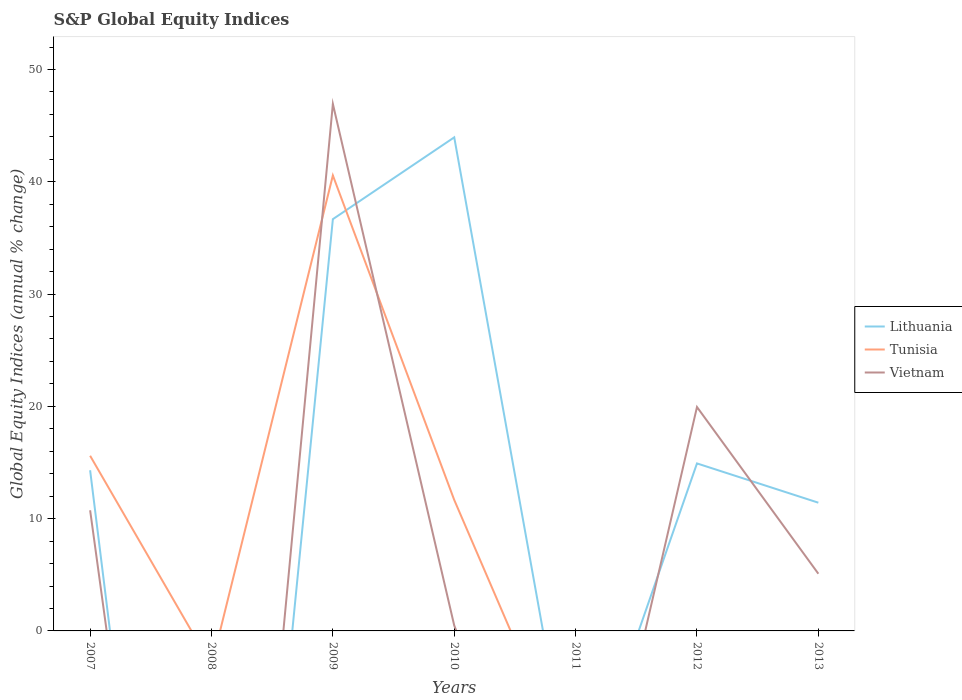Does the line corresponding to Vietnam intersect with the line corresponding to Tunisia?
Provide a succinct answer. Yes. Across all years, what is the maximum global equity indices in Vietnam?
Provide a short and direct response. 0. What is the total global equity indices in Lithuania in the graph?
Give a very brief answer. 21.75. What is the difference between the highest and the second highest global equity indices in Lithuania?
Provide a succinct answer. 43.96. What is the difference between the highest and the lowest global equity indices in Vietnam?
Make the answer very short. 2. Is the global equity indices in Tunisia strictly greater than the global equity indices in Lithuania over the years?
Offer a very short reply. No. How many lines are there?
Your response must be concise. 3. Are the values on the major ticks of Y-axis written in scientific E-notation?
Give a very brief answer. No. Does the graph contain grids?
Offer a terse response. No. How many legend labels are there?
Ensure brevity in your answer.  3. How are the legend labels stacked?
Keep it short and to the point. Vertical. What is the title of the graph?
Offer a terse response. S&P Global Equity Indices. What is the label or title of the X-axis?
Offer a terse response. Years. What is the label or title of the Y-axis?
Ensure brevity in your answer.  Global Equity Indices (annual % change). What is the Global Equity Indices (annual % change) of Lithuania in 2007?
Offer a very short reply. 14.31. What is the Global Equity Indices (annual % change) in Tunisia in 2007?
Your answer should be compact. 15.6. What is the Global Equity Indices (annual % change) in Vietnam in 2007?
Give a very brief answer. 10.74. What is the Global Equity Indices (annual % change) in Lithuania in 2008?
Offer a very short reply. 0. What is the Global Equity Indices (annual % change) of Tunisia in 2008?
Make the answer very short. 0. What is the Global Equity Indices (annual % change) in Lithuania in 2009?
Offer a terse response. 36.67. What is the Global Equity Indices (annual % change) of Tunisia in 2009?
Make the answer very short. 40.57. What is the Global Equity Indices (annual % change) in Vietnam in 2009?
Offer a terse response. 46.93. What is the Global Equity Indices (annual % change) in Lithuania in 2010?
Your response must be concise. 43.96. What is the Global Equity Indices (annual % change) in Tunisia in 2010?
Keep it short and to the point. 11.66. What is the Global Equity Indices (annual % change) in Vietnam in 2010?
Provide a short and direct response. 0.48. What is the Global Equity Indices (annual % change) of Lithuania in 2011?
Keep it short and to the point. 0. What is the Global Equity Indices (annual % change) of Vietnam in 2011?
Your answer should be very brief. 0. What is the Global Equity Indices (annual % change) in Lithuania in 2012?
Keep it short and to the point. 14.92. What is the Global Equity Indices (annual % change) of Tunisia in 2012?
Ensure brevity in your answer.  0. What is the Global Equity Indices (annual % change) in Vietnam in 2012?
Keep it short and to the point. 19.94. What is the Global Equity Indices (annual % change) of Lithuania in 2013?
Offer a very short reply. 11.42. What is the Global Equity Indices (annual % change) in Tunisia in 2013?
Keep it short and to the point. 0. What is the Global Equity Indices (annual % change) in Vietnam in 2013?
Offer a very short reply. 5.09. Across all years, what is the maximum Global Equity Indices (annual % change) in Lithuania?
Ensure brevity in your answer.  43.96. Across all years, what is the maximum Global Equity Indices (annual % change) in Tunisia?
Offer a very short reply. 40.57. Across all years, what is the maximum Global Equity Indices (annual % change) of Vietnam?
Provide a short and direct response. 46.93. Across all years, what is the minimum Global Equity Indices (annual % change) of Vietnam?
Your response must be concise. 0. What is the total Global Equity Indices (annual % change) in Lithuania in the graph?
Offer a terse response. 121.27. What is the total Global Equity Indices (annual % change) in Tunisia in the graph?
Offer a very short reply. 67.83. What is the total Global Equity Indices (annual % change) of Vietnam in the graph?
Keep it short and to the point. 83.19. What is the difference between the Global Equity Indices (annual % change) in Lithuania in 2007 and that in 2009?
Your answer should be compact. -22.36. What is the difference between the Global Equity Indices (annual % change) in Tunisia in 2007 and that in 2009?
Make the answer very short. -24.97. What is the difference between the Global Equity Indices (annual % change) in Vietnam in 2007 and that in 2009?
Make the answer very short. -36.19. What is the difference between the Global Equity Indices (annual % change) in Lithuania in 2007 and that in 2010?
Provide a succinct answer. -29.65. What is the difference between the Global Equity Indices (annual % change) in Tunisia in 2007 and that in 2010?
Your response must be concise. 3.94. What is the difference between the Global Equity Indices (annual % change) of Vietnam in 2007 and that in 2010?
Ensure brevity in your answer.  10.26. What is the difference between the Global Equity Indices (annual % change) of Lithuania in 2007 and that in 2012?
Offer a very short reply. -0.61. What is the difference between the Global Equity Indices (annual % change) of Vietnam in 2007 and that in 2012?
Keep it short and to the point. -9.2. What is the difference between the Global Equity Indices (annual % change) in Lithuania in 2007 and that in 2013?
Your answer should be compact. 2.89. What is the difference between the Global Equity Indices (annual % change) of Vietnam in 2007 and that in 2013?
Your answer should be compact. 5.65. What is the difference between the Global Equity Indices (annual % change) in Lithuania in 2009 and that in 2010?
Your response must be concise. -7.29. What is the difference between the Global Equity Indices (annual % change) in Tunisia in 2009 and that in 2010?
Provide a short and direct response. 28.9. What is the difference between the Global Equity Indices (annual % change) of Vietnam in 2009 and that in 2010?
Ensure brevity in your answer.  46.45. What is the difference between the Global Equity Indices (annual % change) of Lithuania in 2009 and that in 2012?
Provide a short and direct response. 21.75. What is the difference between the Global Equity Indices (annual % change) of Vietnam in 2009 and that in 2012?
Make the answer very short. 26.99. What is the difference between the Global Equity Indices (annual % change) of Lithuania in 2009 and that in 2013?
Provide a succinct answer. 25.25. What is the difference between the Global Equity Indices (annual % change) in Vietnam in 2009 and that in 2013?
Keep it short and to the point. 41.84. What is the difference between the Global Equity Indices (annual % change) in Lithuania in 2010 and that in 2012?
Keep it short and to the point. 29.04. What is the difference between the Global Equity Indices (annual % change) of Vietnam in 2010 and that in 2012?
Offer a terse response. -19.46. What is the difference between the Global Equity Indices (annual % change) in Lithuania in 2010 and that in 2013?
Your answer should be compact. 32.54. What is the difference between the Global Equity Indices (annual % change) of Vietnam in 2010 and that in 2013?
Your answer should be compact. -4.61. What is the difference between the Global Equity Indices (annual % change) of Lithuania in 2012 and that in 2013?
Ensure brevity in your answer.  3.5. What is the difference between the Global Equity Indices (annual % change) of Vietnam in 2012 and that in 2013?
Provide a succinct answer. 14.85. What is the difference between the Global Equity Indices (annual % change) of Lithuania in 2007 and the Global Equity Indices (annual % change) of Tunisia in 2009?
Offer a very short reply. -26.26. What is the difference between the Global Equity Indices (annual % change) of Lithuania in 2007 and the Global Equity Indices (annual % change) of Vietnam in 2009?
Provide a succinct answer. -32.63. What is the difference between the Global Equity Indices (annual % change) of Tunisia in 2007 and the Global Equity Indices (annual % change) of Vietnam in 2009?
Your answer should be compact. -31.33. What is the difference between the Global Equity Indices (annual % change) of Lithuania in 2007 and the Global Equity Indices (annual % change) of Tunisia in 2010?
Give a very brief answer. 2.64. What is the difference between the Global Equity Indices (annual % change) in Lithuania in 2007 and the Global Equity Indices (annual % change) in Vietnam in 2010?
Keep it short and to the point. 13.83. What is the difference between the Global Equity Indices (annual % change) of Tunisia in 2007 and the Global Equity Indices (annual % change) of Vietnam in 2010?
Keep it short and to the point. 15.12. What is the difference between the Global Equity Indices (annual % change) of Lithuania in 2007 and the Global Equity Indices (annual % change) of Vietnam in 2012?
Your answer should be compact. -5.63. What is the difference between the Global Equity Indices (annual % change) in Tunisia in 2007 and the Global Equity Indices (annual % change) in Vietnam in 2012?
Provide a short and direct response. -4.34. What is the difference between the Global Equity Indices (annual % change) in Lithuania in 2007 and the Global Equity Indices (annual % change) in Vietnam in 2013?
Provide a succinct answer. 9.21. What is the difference between the Global Equity Indices (annual % change) of Tunisia in 2007 and the Global Equity Indices (annual % change) of Vietnam in 2013?
Provide a succinct answer. 10.51. What is the difference between the Global Equity Indices (annual % change) of Lithuania in 2009 and the Global Equity Indices (annual % change) of Tunisia in 2010?
Provide a succinct answer. 25.01. What is the difference between the Global Equity Indices (annual % change) of Lithuania in 2009 and the Global Equity Indices (annual % change) of Vietnam in 2010?
Your answer should be compact. 36.19. What is the difference between the Global Equity Indices (annual % change) of Tunisia in 2009 and the Global Equity Indices (annual % change) of Vietnam in 2010?
Make the answer very short. 40.08. What is the difference between the Global Equity Indices (annual % change) of Lithuania in 2009 and the Global Equity Indices (annual % change) of Vietnam in 2012?
Provide a short and direct response. 16.73. What is the difference between the Global Equity Indices (annual % change) of Tunisia in 2009 and the Global Equity Indices (annual % change) of Vietnam in 2012?
Ensure brevity in your answer.  20.62. What is the difference between the Global Equity Indices (annual % change) of Lithuania in 2009 and the Global Equity Indices (annual % change) of Vietnam in 2013?
Your answer should be very brief. 31.58. What is the difference between the Global Equity Indices (annual % change) in Tunisia in 2009 and the Global Equity Indices (annual % change) in Vietnam in 2013?
Offer a very short reply. 35.47. What is the difference between the Global Equity Indices (annual % change) of Lithuania in 2010 and the Global Equity Indices (annual % change) of Vietnam in 2012?
Offer a terse response. 24.02. What is the difference between the Global Equity Indices (annual % change) in Tunisia in 2010 and the Global Equity Indices (annual % change) in Vietnam in 2012?
Give a very brief answer. -8.28. What is the difference between the Global Equity Indices (annual % change) in Lithuania in 2010 and the Global Equity Indices (annual % change) in Vietnam in 2013?
Your response must be concise. 38.86. What is the difference between the Global Equity Indices (annual % change) of Tunisia in 2010 and the Global Equity Indices (annual % change) of Vietnam in 2013?
Offer a terse response. 6.57. What is the difference between the Global Equity Indices (annual % change) of Lithuania in 2012 and the Global Equity Indices (annual % change) of Vietnam in 2013?
Offer a terse response. 9.82. What is the average Global Equity Indices (annual % change) in Lithuania per year?
Your answer should be very brief. 17.32. What is the average Global Equity Indices (annual % change) of Tunisia per year?
Ensure brevity in your answer.  9.69. What is the average Global Equity Indices (annual % change) of Vietnam per year?
Offer a very short reply. 11.88. In the year 2007, what is the difference between the Global Equity Indices (annual % change) of Lithuania and Global Equity Indices (annual % change) of Tunisia?
Offer a very short reply. -1.29. In the year 2007, what is the difference between the Global Equity Indices (annual % change) in Lithuania and Global Equity Indices (annual % change) in Vietnam?
Ensure brevity in your answer.  3.56. In the year 2007, what is the difference between the Global Equity Indices (annual % change) of Tunisia and Global Equity Indices (annual % change) of Vietnam?
Give a very brief answer. 4.86. In the year 2009, what is the difference between the Global Equity Indices (annual % change) in Lithuania and Global Equity Indices (annual % change) in Tunisia?
Offer a terse response. -3.89. In the year 2009, what is the difference between the Global Equity Indices (annual % change) in Lithuania and Global Equity Indices (annual % change) in Vietnam?
Provide a short and direct response. -10.26. In the year 2009, what is the difference between the Global Equity Indices (annual % change) in Tunisia and Global Equity Indices (annual % change) in Vietnam?
Your answer should be compact. -6.37. In the year 2010, what is the difference between the Global Equity Indices (annual % change) in Lithuania and Global Equity Indices (annual % change) in Tunisia?
Your response must be concise. 32.29. In the year 2010, what is the difference between the Global Equity Indices (annual % change) in Lithuania and Global Equity Indices (annual % change) in Vietnam?
Your answer should be compact. 43.48. In the year 2010, what is the difference between the Global Equity Indices (annual % change) in Tunisia and Global Equity Indices (annual % change) in Vietnam?
Your answer should be very brief. 11.18. In the year 2012, what is the difference between the Global Equity Indices (annual % change) of Lithuania and Global Equity Indices (annual % change) of Vietnam?
Offer a very short reply. -5.02. In the year 2013, what is the difference between the Global Equity Indices (annual % change) in Lithuania and Global Equity Indices (annual % change) in Vietnam?
Your answer should be compact. 6.33. What is the ratio of the Global Equity Indices (annual % change) in Lithuania in 2007 to that in 2009?
Keep it short and to the point. 0.39. What is the ratio of the Global Equity Indices (annual % change) in Tunisia in 2007 to that in 2009?
Your answer should be very brief. 0.38. What is the ratio of the Global Equity Indices (annual % change) in Vietnam in 2007 to that in 2009?
Offer a very short reply. 0.23. What is the ratio of the Global Equity Indices (annual % change) of Lithuania in 2007 to that in 2010?
Give a very brief answer. 0.33. What is the ratio of the Global Equity Indices (annual % change) in Tunisia in 2007 to that in 2010?
Offer a terse response. 1.34. What is the ratio of the Global Equity Indices (annual % change) of Vietnam in 2007 to that in 2010?
Offer a very short reply. 22.36. What is the ratio of the Global Equity Indices (annual % change) of Lithuania in 2007 to that in 2012?
Your response must be concise. 0.96. What is the ratio of the Global Equity Indices (annual % change) of Vietnam in 2007 to that in 2012?
Ensure brevity in your answer.  0.54. What is the ratio of the Global Equity Indices (annual % change) of Lithuania in 2007 to that in 2013?
Offer a terse response. 1.25. What is the ratio of the Global Equity Indices (annual % change) in Vietnam in 2007 to that in 2013?
Provide a succinct answer. 2.11. What is the ratio of the Global Equity Indices (annual % change) in Lithuania in 2009 to that in 2010?
Keep it short and to the point. 0.83. What is the ratio of the Global Equity Indices (annual % change) in Tunisia in 2009 to that in 2010?
Ensure brevity in your answer.  3.48. What is the ratio of the Global Equity Indices (annual % change) of Vietnam in 2009 to that in 2010?
Make the answer very short. 97.67. What is the ratio of the Global Equity Indices (annual % change) of Lithuania in 2009 to that in 2012?
Provide a short and direct response. 2.46. What is the ratio of the Global Equity Indices (annual % change) in Vietnam in 2009 to that in 2012?
Make the answer very short. 2.35. What is the ratio of the Global Equity Indices (annual % change) in Lithuania in 2009 to that in 2013?
Your answer should be compact. 3.21. What is the ratio of the Global Equity Indices (annual % change) in Vietnam in 2009 to that in 2013?
Your answer should be very brief. 9.21. What is the ratio of the Global Equity Indices (annual % change) of Lithuania in 2010 to that in 2012?
Offer a very short reply. 2.95. What is the ratio of the Global Equity Indices (annual % change) in Vietnam in 2010 to that in 2012?
Offer a very short reply. 0.02. What is the ratio of the Global Equity Indices (annual % change) in Lithuania in 2010 to that in 2013?
Make the answer very short. 3.85. What is the ratio of the Global Equity Indices (annual % change) of Vietnam in 2010 to that in 2013?
Offer a terse response. 0.09. What is the ratio of the Global Equity Indices (annual % change) in Lithuania in 2012 to that in 2013?
Ensure brevity in your answer.  1.31. What is the ratio of the Global Equity Indices (annual % change) in Vietnam in 2012 to that in 2013?
Your response must be concise. 3.91. What is the difference between the highest and the second highest Global Equity Indices (annual % change) in Lithuania?
Ensure brevity in your answer.  7.29. What is the difference between the highest and the second highest Global Equity Indices (annual % change) in Tunisia?
Provide a short and direct response. 24.97. What is the difference between the highest and the second highest Global Equity Indices (annual % change) in Vietnam?
Your answer should be compact. 26.99. What is the difference between the highest and the lowest Global Equity Indices (annual % change) in Lithuania?
Make the answer very short. 43.96. What is the difference between the highest and the lowest Global Equity Indices (annual % change) of Tunisia?
Give a very brief answer. 40.57. What is the difference between the highest and the lowest Global Equity Indices (annual % change) in Vietnam?
Offer a terse response. 46.93. 